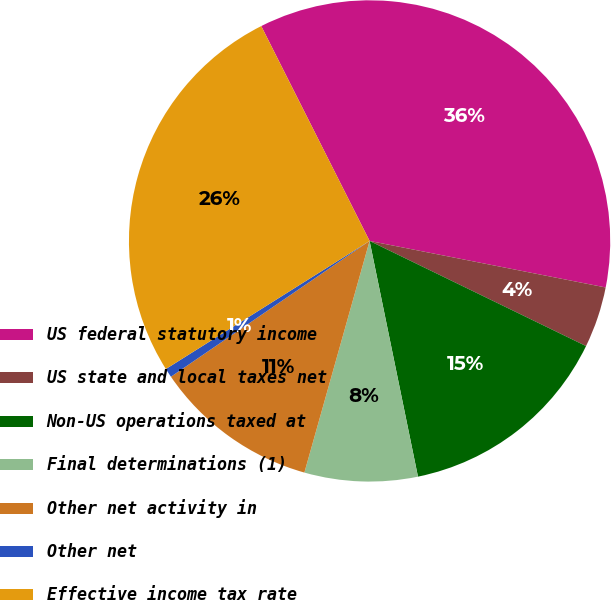Convert chart. <chart><loc_0><loc_0><loc_500><loc_500><pie_chart><fcel>US federal statutory income<fcel>US state and local taxes net<fcel>Non-US operations taxed at<fcel>Final determinations (1)<fcel>Other net activity in<fcel>Other net<fcel>Effective income tax rate<nl><fcel>35.53%<fcel>4.1%<fcel>14.58%<fcel>7.59%<fcel>11.09%<fcel>0.61%<fcel>26.5%<nl></chart> 